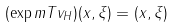<formula> <loc_0><loc_0><loc_500><loc_500>( \exp m T v _ { H } ) ( x , \xi ) = ( x , \xi )</formula> 